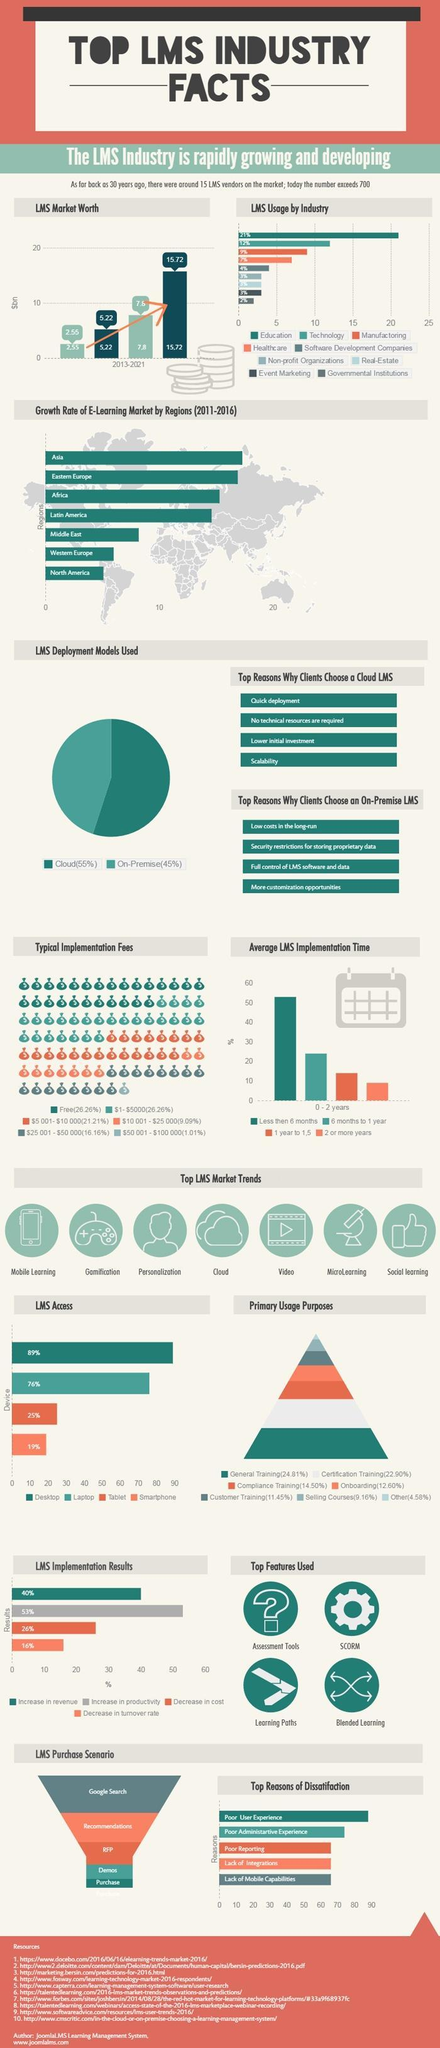By what percentage has the productivity increased as a result of LMS implementation?
Answer the question with a short phrase. 53% What is the trend of the LMS Market Worth since 2013 - increase, decrease or stable ? Increase Which LMS deployment model requires higher cost in the long run ? Cloud LMS Which industry shows a 4% LMS usage ? Software development companies By how much is the the LMS usage of education industry higher than that of of the healthcare industry ? 14% Name the countries whose growth rate in the e-Learning market is less than 10% ? Middle East, Western Europe, North America How many industries use LMS ? 9 Which LMS deployment model requires higher initial investment ? On-premise What is the percentage of  LMS usage in the manufacturing industry ? 9% Which region in Europe shows higher growth rate of E-Learning market- North, West, East or South ? East 